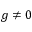<formula> <loc_0><loc_0><loc_500><loc_500>g \neq 0</formula> 